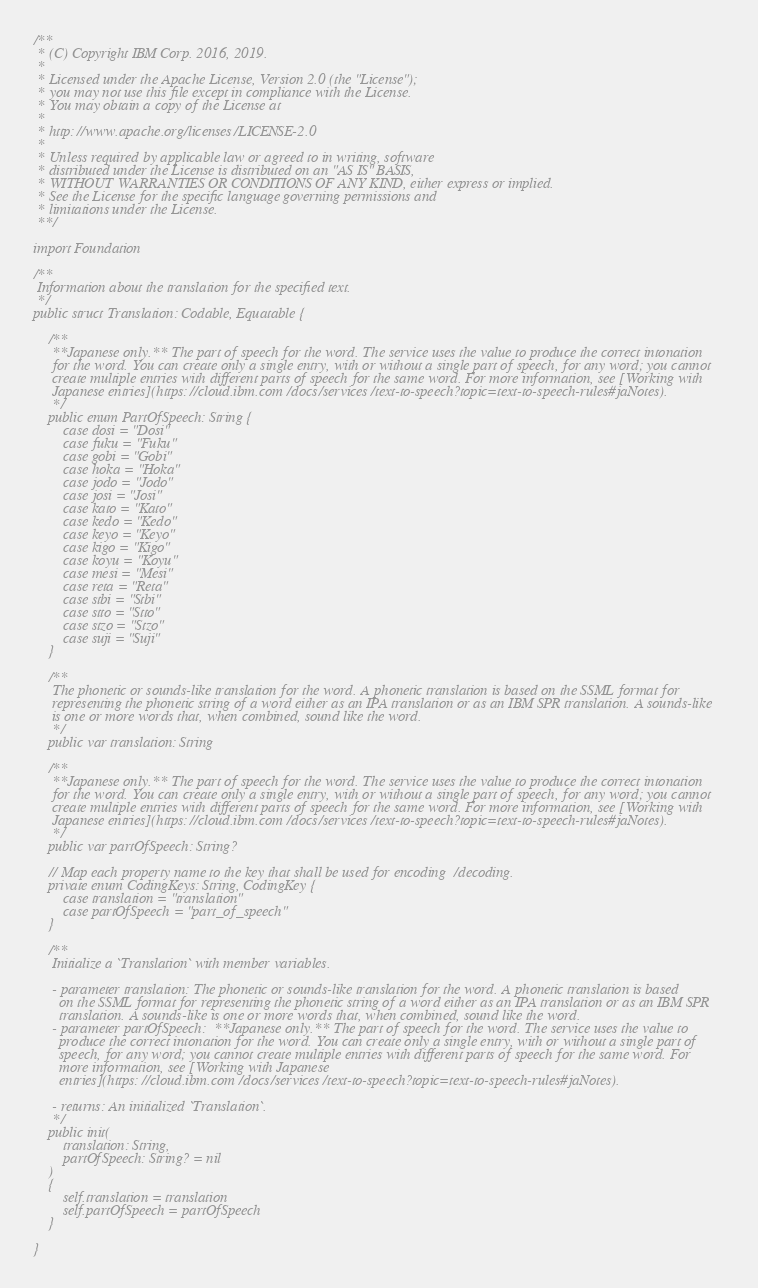<code> <loc_0><loc_0><loc_500><loc_500><_Swift_>/**
 * (C) Copyright IBM Corp. 2016, 2019.
 *
 * Licensed under the Apache License, Version 2.0 (the "License");
 * you may not use this file except in compliance with the License.
 * You may obtain a copy of the License at
 *
 * http://www.apache.org/licenses/LICENSE-2.0
 *
 * Unless required by applicable law or agreed to in writing, software
 * distributed under the License is distributed on an "AS IS" BASIS,
 * WITHOUT WARRANTIES OR CONDITIONS OF ANY KIND, either express or implied.
 * See the License for the specific language governing permissions and
 * limitations under the License.
 **/

import Foundation

/**
 Information about the translation for the specified text.
 */
public struct Translation: Codable, Equatable {

    /**
     **Japanese only.** The part of speech for the word. The service uses the value to produce the correct intonation
     for the word. You can create only a single entry, with or without a single part of speech, for any word; you cannot
     create multiple entries with different parts of speech for the same word. For more information, see [Working with
     Japanese entries](https://cloud.ibm.com/docs/services/text-to-speech?topic=text-to-speech-rules#jaNotes).
     */
    public enum PartOfSpeech: String {
        case dosi = "Dosi"
        case fuku = "Fuku"
        case gobi = "Gobi"
        case hoka = "Hoka"
        case jodo = "Jodo"
        case josi = "Josi"
        case kato = "Kato"
        case kedo = "Kedo"
        case keyo = "Keyo"
        case kigo = "Kigo"
        case koyu = "Koyu"
        case mesi = "Mesi"
        case reta = "Reta"
        case stbi = "Stbi"
        case stto = "Stto"
        case stzo = "Stzo"
        case suji = "Suji"
    }

    /**
     The phonetic or sounds-like translation for the word. A phonetic translation is based on the SSML format for
     representing the phonetic string of a word either as an IPA translation or as an IBM SPR translation. A sounds-like
     is one or more words that, when combined, sound like the word.
     */
    public var translation: String

    /**
     **Japanese only.** The part of speech for the word. The service uses the value to produce the correct intonation
     for the word. You can create only a single entry, with or without a single part of speech, for any word; you cannot
     create multiple entries with different parts of speech for the same word. For more information, see [Working with
     Japanese entries](https://cloud.ibm.com/docs/services/text-to-speech?topic=text-to-speech-rules#jaNotes).
     */
    public var partOfSpeech: String?

    // Map each property name to the key that shall be used for encoding/decoding.
    private enum CodingKeys: String, CodingKey {
        case translation = "translation"
        case partOfSpeech = "part_of_speech"
    }

    /**
     Initialize a `Translation` with member variables.

     - parameter translation: The phonetic or sounds-like translation for the word. A phonetic translation is based
       on the SSML format for representing the phonetic string of a word either as an IPA translation or as an IBM SPR
       translation. A sounds-like is one or more words that, when combined, sound like the word.
     - parameter partOfSpeech: **Japanese only.** The part of speech for the word. The service uses the value to
       produce the correct intonation for the word. You can create only a single entry, with or without a single part of
       speech, for any word; you cannot create multiple entries with different parts of speech for the same word. For
       more information, see [Working with Japanese
       entries](https://cloud.ibm.com/docs/services/text-to-speech?topic=text-to-speech-rules#jaNotes).

     - returns: An initialized `Translation`.
     */
    public init(
        translation: String,
        partOfSpeech: String? = nil
    )
    {
        self.translation = translation
        self.partOfSpeech = partOfSpeech
    }

}
</code> 